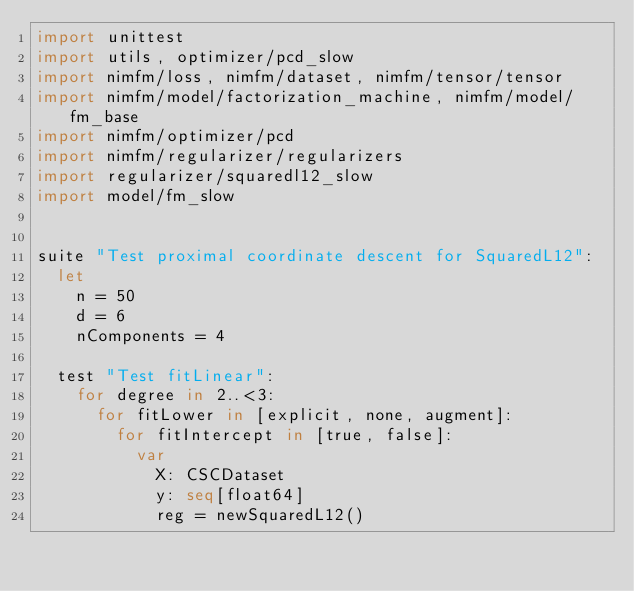<code> <loc_0><loc_0><loc_500><loc_500><_Nim_>import unittest
import utils, optimizer/pcd_slow
import nimfm/loss, nimfm/dataset, nimfm/tensor/tensor
import nimfm/model/factorization_machine, nimfm/model/fm_base
import nimfm/optimizer/pcd
import nimfm/regularizer/regularizers
import regularizer/squaredl12_slow
import model/fm_slow


suite "Test proximal coordinate descent for SquaredL12":
  let
    n = 50
    d = 6
    nComponents = 4

  test "Test fitLinear":
    for degree in 2..<3:
      for fitLower in [explicit, none, augment]:
        for fitIntercept in [true, false]:
          var
            X: CSCDataset
            y: seq[float64]
            reg = newSquaredL12()</code> 